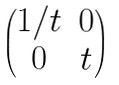<formula> <loc_0><loc_0><loc_500><loc_500>\begin{pmatrix} 1 / t & 0 \\ 0 & t \end{pmatrix}</formula> 